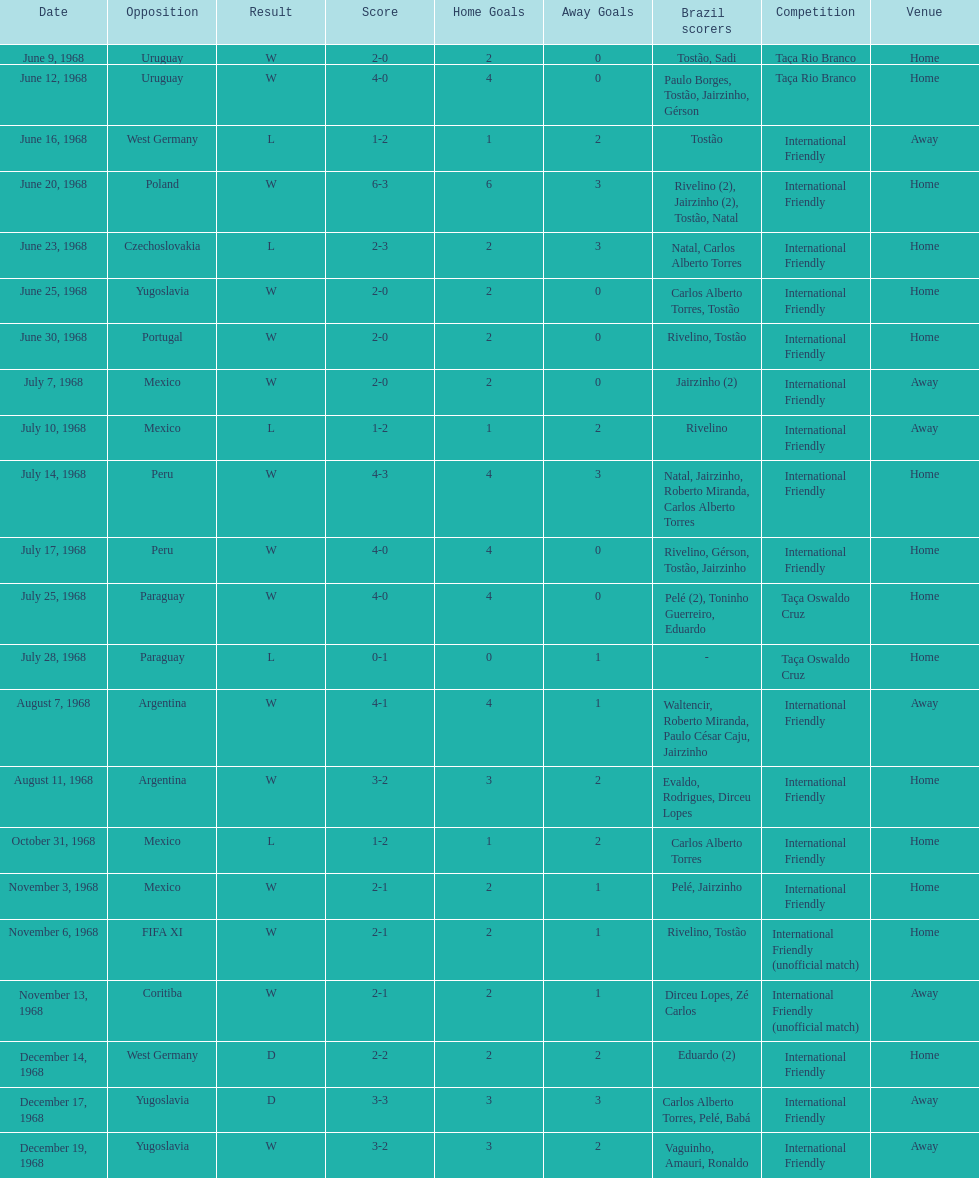What is the cumulative number of ties? 2. 